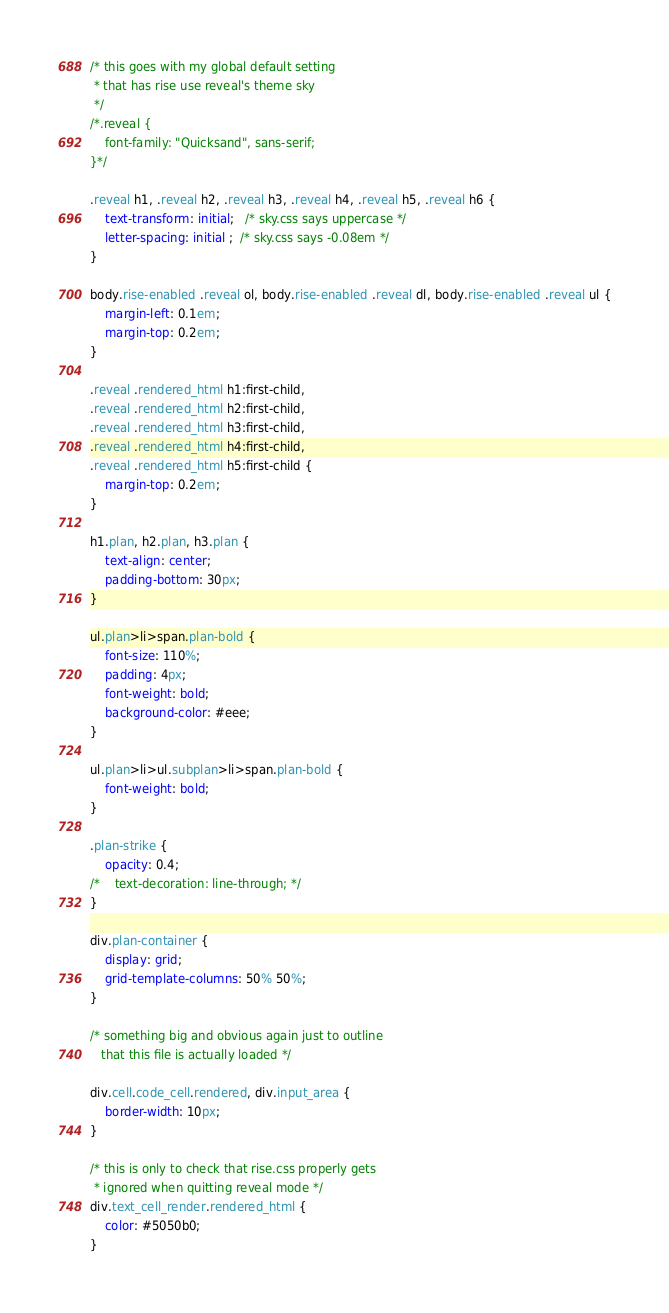<code> <loc_0><loc_0><loc_500><loc_500><_CSS_>/* this goes with my global default setting
 * that has rise use reveal's theme sky
 */
/*.reveal {
    font-family: "Quicksand", sans-serif;
}*/

.reveal h1, .reveal h2, .reveal h3, .reveal h4, .reveal h5, .reveal h6 {
    text-transform: initial;   /* sky.css says uppercase */
    letter-spacing: initial ;  /* sky.css says -0.08em */
}

body.rise-enabled .reveal ol, body.rise-enabled .reveal dl, body.rise-enabled .reveal ul {
    margin-left: 0.1em;
    margin-top: 0.2em;
}

.reveal .rendered_html h1:first-child,
.reveal .rendered_html h2:first-child,
.reveal .rendered_html h3:first-child,
.reveal .rendered_html h4:first-child,
.reveal .rendered_html h5:first-child {
    margin-top: 0.2em;
}

h1.plan, h2.plan, h3.plan {
    text-align: center;
    padding-bottom: 30px;
}

ul.plan>li>span.plan-bold {
    font-size: 110%;
    padding: 4px;
    font-weight: bold;
    background-color: #eee;
}

ul.plan>li>ul.subplan>li>span.plan-bold {
    font-weight: bold;
}

.plan-strike {
    opacity: 0.4;
/*    text-decoration: line-through; */
}

div.plan-container {
    display: grid;
    grid-template-columns: 50% 50%;
}

/* something big and obvious again just to outline
   that this file is actually loaded */

div.cell.code_cell.rendered, div.input_area {
    border-width: 10px;
}

/* this is only to check that rise.css properly gets
 * ignored when quitting reveal mode */
div.text_cell_render.rendered_html {
    color: #5050b0;
}</code> 